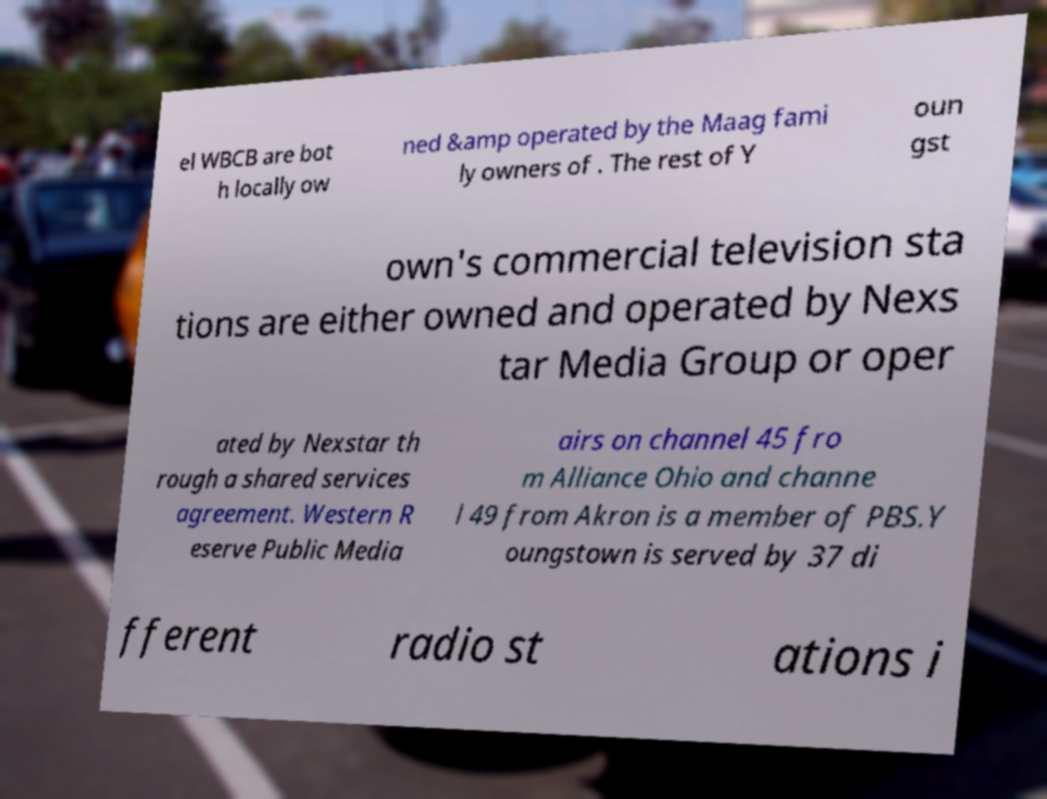For documentation purposes, I need the text within this image transcribed. Could you provide that? el WBCB are bot h locally ow ned &amp operated by the Maag fami ly owners of . The rest of Y oun gst own's commercial television sta tions are either owned and operated by Nexs tar Media Group or oper ated by Nexstar th rough a shared services agreement. Western R eserve Public Media airs on channel 45 fro m Alliance Ohio and channe l 49 from Akron is a member of PBS.Y oungstown is served by 37 di fferent radio st ations i 